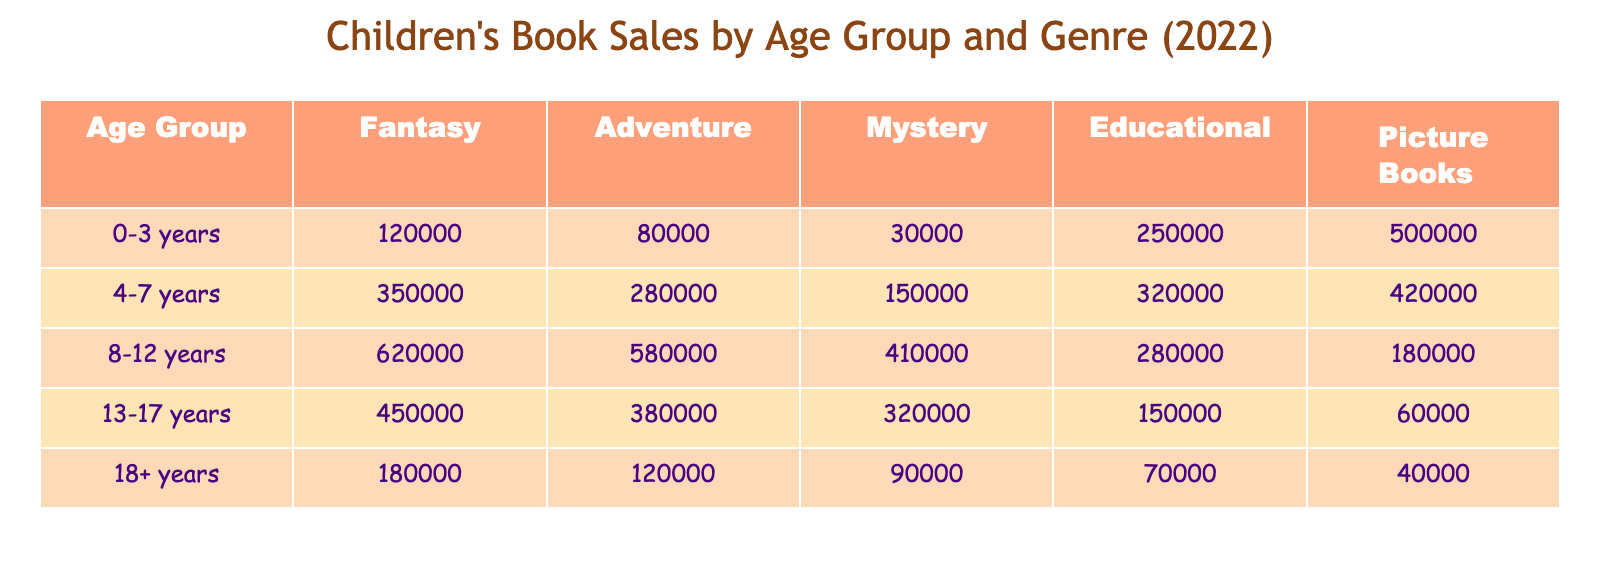What age group has the highest sales in the fantasy genre? The table indicates that the 8-12 years age group has the highest sales in the fantasy genre, with a total of 620,000 units sold.
Answer: 8-12 years What is the total number of educational books sold across all age groups? By adding the sales for educational books in each age group: 250,000 (0-3 years) + 320,000 (4-7 years) + 280,000 (8-12 years) + 150,000 (13-17 years) + 70,000 (18+ years) = 1,070,000 total educational books sold.
Answer: 1,070,000 How many more picture books were sold to the 0-3 years age group compared to the 13-17 years age group? The table shows 500,000 sales for the 0-3 years age group and 60,000 for the 13-17 years age group. The difference is 500,000 - 60,000 = 440,000.
Answer: 440,000 Are educational books the most popular genre for the 4-7 years age group? The educational books sold in the 4-7 years age group total 320,000, which is less than the sales for picture books (420,000) and fantasy (350,000), confirming educational books are not the most popular.
Answer: No What is the average number of adventure books sold per age group? The total sales for adventure books across all age groups is 80,000 + 280,000 + 580,000 + 380,000 + 120,000 = 1,440,000. There are 5 age groups, so the average is 1,440,000 / 5 = 288,000.
Answer: 288,000 Which age group has the lowest sales in the mystery genre, and what are those sales? The sales for the mystery genre in the age groups are: 30,000 (0-3 years), 150,000 (4-7 years), 410,000 (8-12 years), 320,000 (13-17 years), and 90,000 (18+ years). The lowest is 30,000 for the 0-3 years age group.
Answer: 0-3 years, 30,000 What percentage of total sales do picture books comprise for the 8-12 years age group? First, add the total sales for the 8-12 years age group: 620,000 + 580,000 + 410,000 + 280,000 + 180,000 = 2,070,000. Picture books sold are 180,000, so the percentage is (180,000 / 2,070,000) * 100 ≈ 8.7%.
Answer: Approximately 8.7% Which genre sold over 400,000 copies in the 4-7 years age group? Looking at the sales data for the 4-7 years age group, we see fantasy (350,000), adventure (280,000), mystery (150,000), educational (320,000), and picture books (420,000). Only picture books is over 400,000.
Answer: Picture Books In which genre did the 18+ years age group have higher sales compared to the mystery genre? The 18+ years age group had sales of 180,000 in fantasy and 120,000 in adventure, both of which are higher than the mystery sales of 90,000. So, fantasy and adventure are the genres with higher sales.
Answer: Fantasy and Adventure 